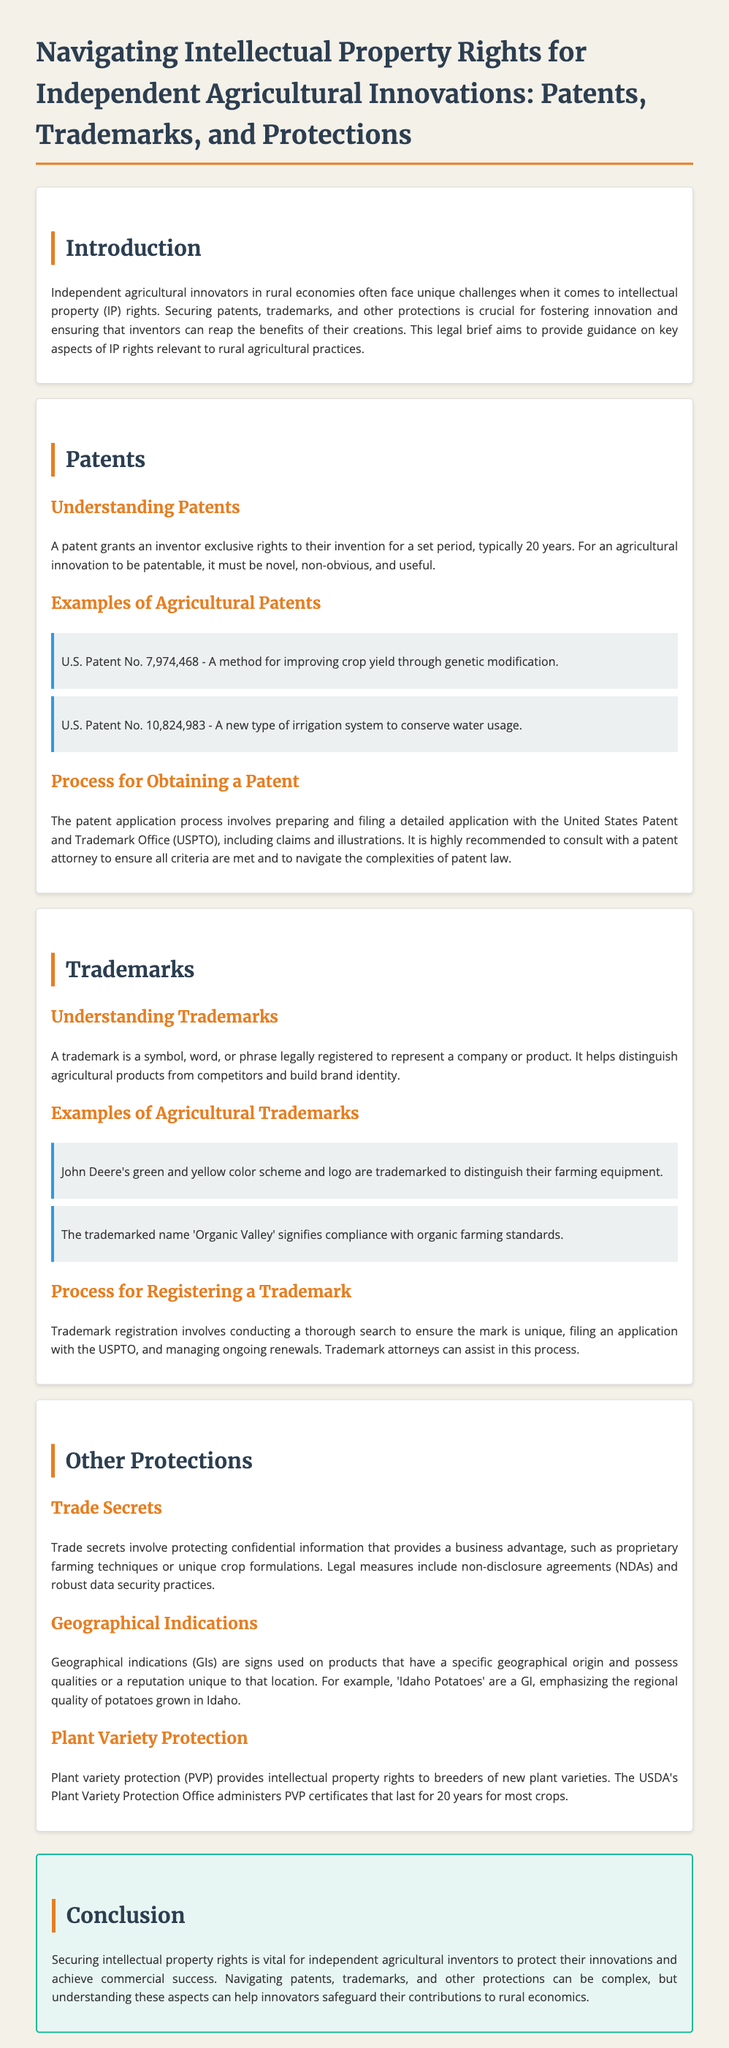What does a patent grant? A patent grants an inventor exclusive rights to their invention for a set period; this is discussed in the section on patents.
Answer: Exclusive rights What is the typical duration of a patent? The document specifies that a patent typically lasts for a set period, which is mentioned in the patents section.
Answer: 20 years Name one example of an agricultural patent. The document provides examples of agricultural patents, including U.S. Patent No. 7,974,468, which is cited in the patents section.
Answer: U.S. Patent No. 7,974,468 What is the purpose of a trademark? The legal brief states that a trademark helps distinguish agricultural products from competitors, found in the trademarks section.
Answer: Distinguish products Who administers plant variety protection certificates? The document mentions that the USDA's Plant Variety Protection Office administers PVP certificates in the other protections section.
Answer: USDA What is a trade secret? A trade secret involves protecting confidential information that provides a business advantage, as defined in the other protections section.
Answer: Confidential information What must an agricultural innovation be in order to be patentable? The document describes criteria for patentability in the patents section, detailing necessary characteristics for an agricultural innovation.
Answer: Novel, non-obvious, and useful What is an example of a geographical indication? The legal brief provides an example of a geographical indication, ‘Idaho Potatoes’, in the other protections section.
Answer: Idaho Potatoes What can trademark attorneys assist with? The document outlines that trademark attorneys can assist with the process of trademark registration as stated in the trademarks section.
Answer: Trademark registration 